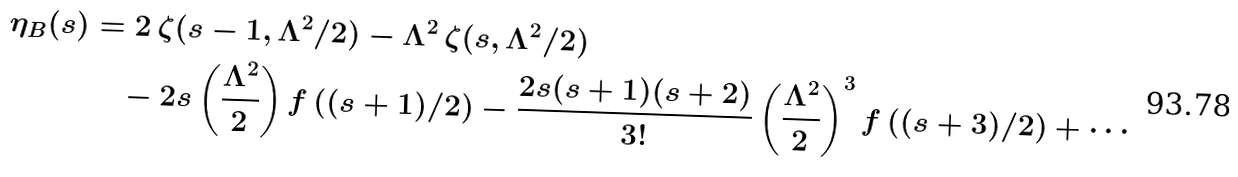<formula> <loc_0><loc_0><loc_500><loc_500>\eta _ { B } ( s ) & = 2 \, \zeta ( s - 1 , \Lambda ^ { 2 } / 2 ) - \Lambda ^ { 2 } \, \zeta ( s , \Lambda ^ { 2 } / 2 ) \\ & \quad - 2 s \left ( \frac { \Lambda ^ { 2 } } { 2 } \right ) f \left ( ( s + 1 ) / 2 \right ) - \frac { 2 s ( s + 1 ) ( s + 2 ) } { 3 ! } \left ( \frac { \Lambda ^ { 2 } } { 2 } \right ) ^ { 3 } f \left ( ( s + 3 ) / 2 \right ) + \cdots</formula> 